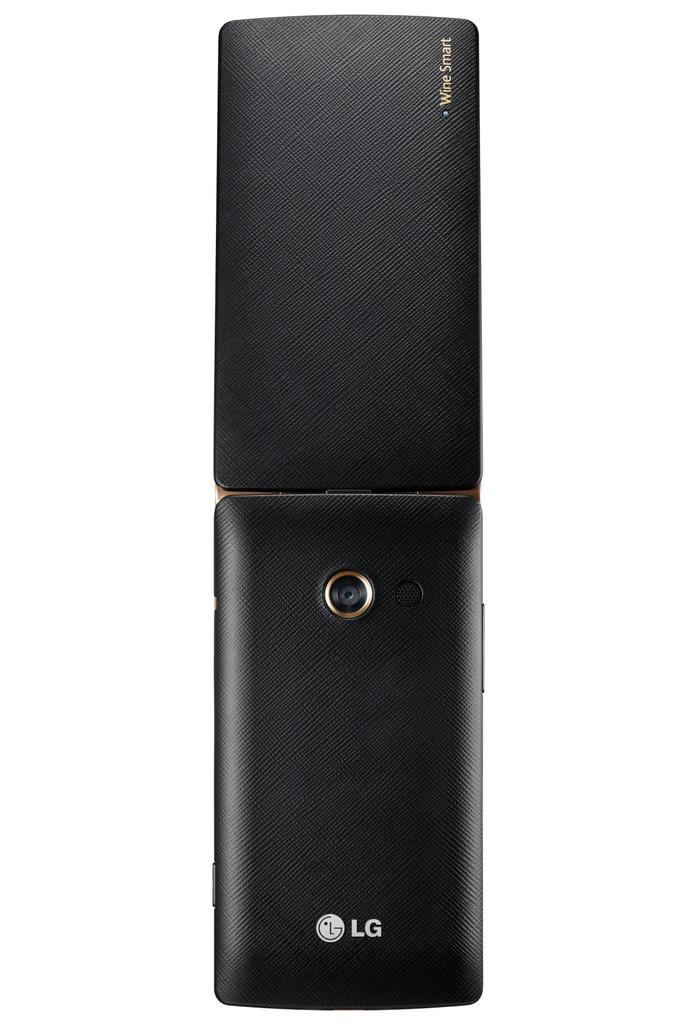<image>
Relay a brief, clear account of the picture shown. The device has LG branding along with the words Wine Smart. 